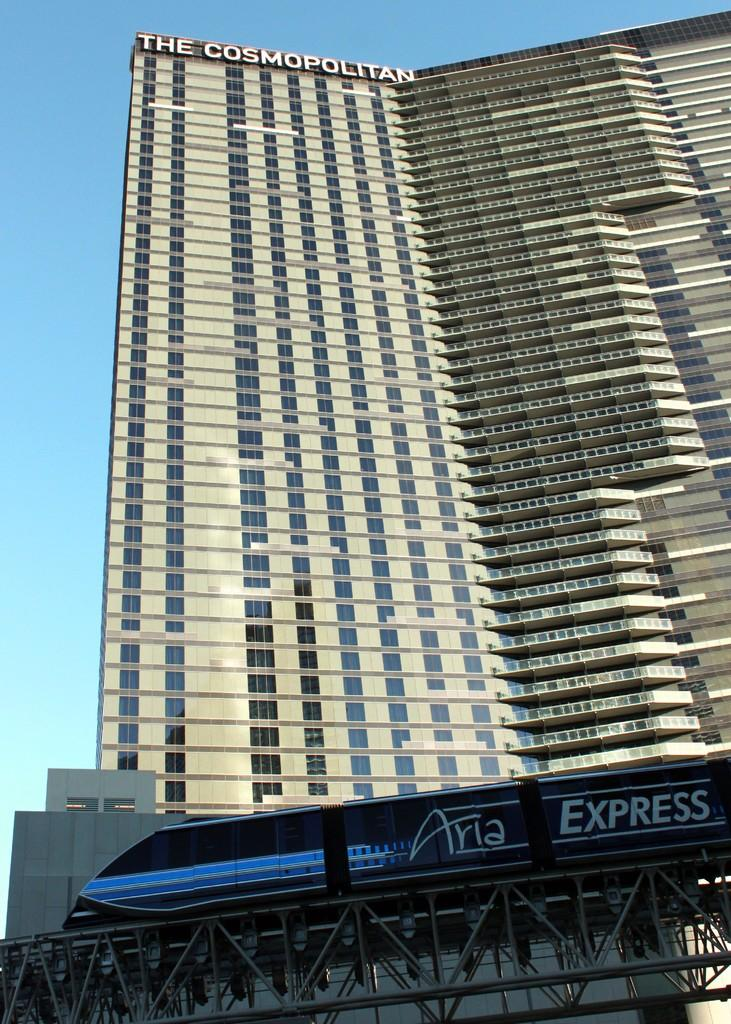<image>
Describe the image concisely. The Cosmopolitan shown from the ground looking up 